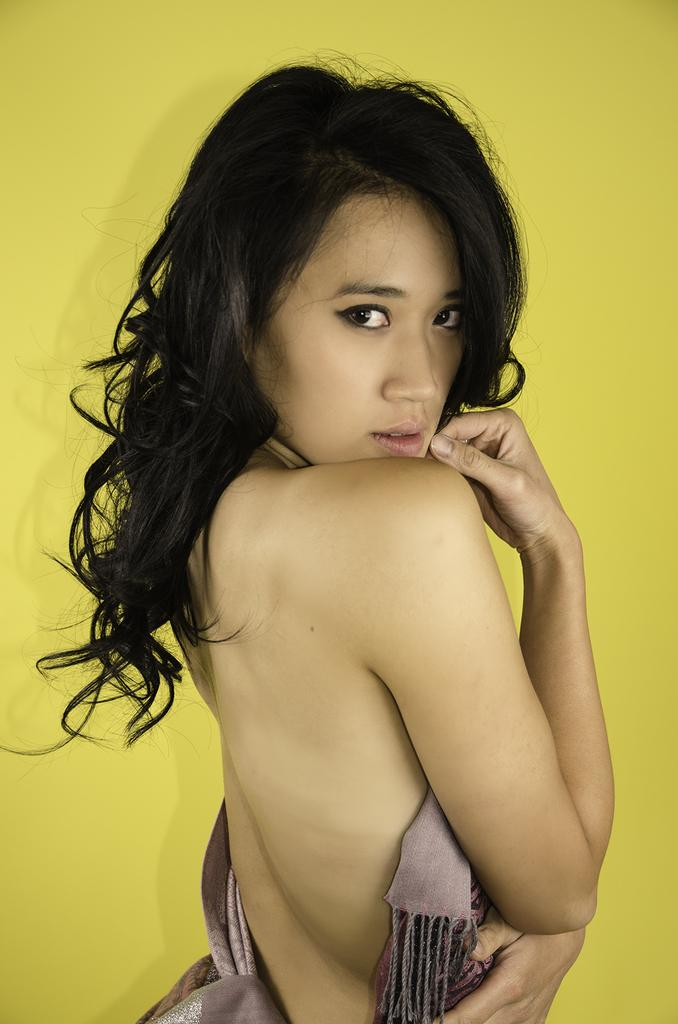What is the main subject of the image? The main subject of the image is a woman. Can you describe the background of the image? The background of the image is yellow. What type of home can be seen in the background of the image? There is no home visible in the image; the background is yellow. What emotion can be observed on the woman's face in the image? The provided facts do not mention any emotions or facial expressions, so it cannot be determined from the image. 